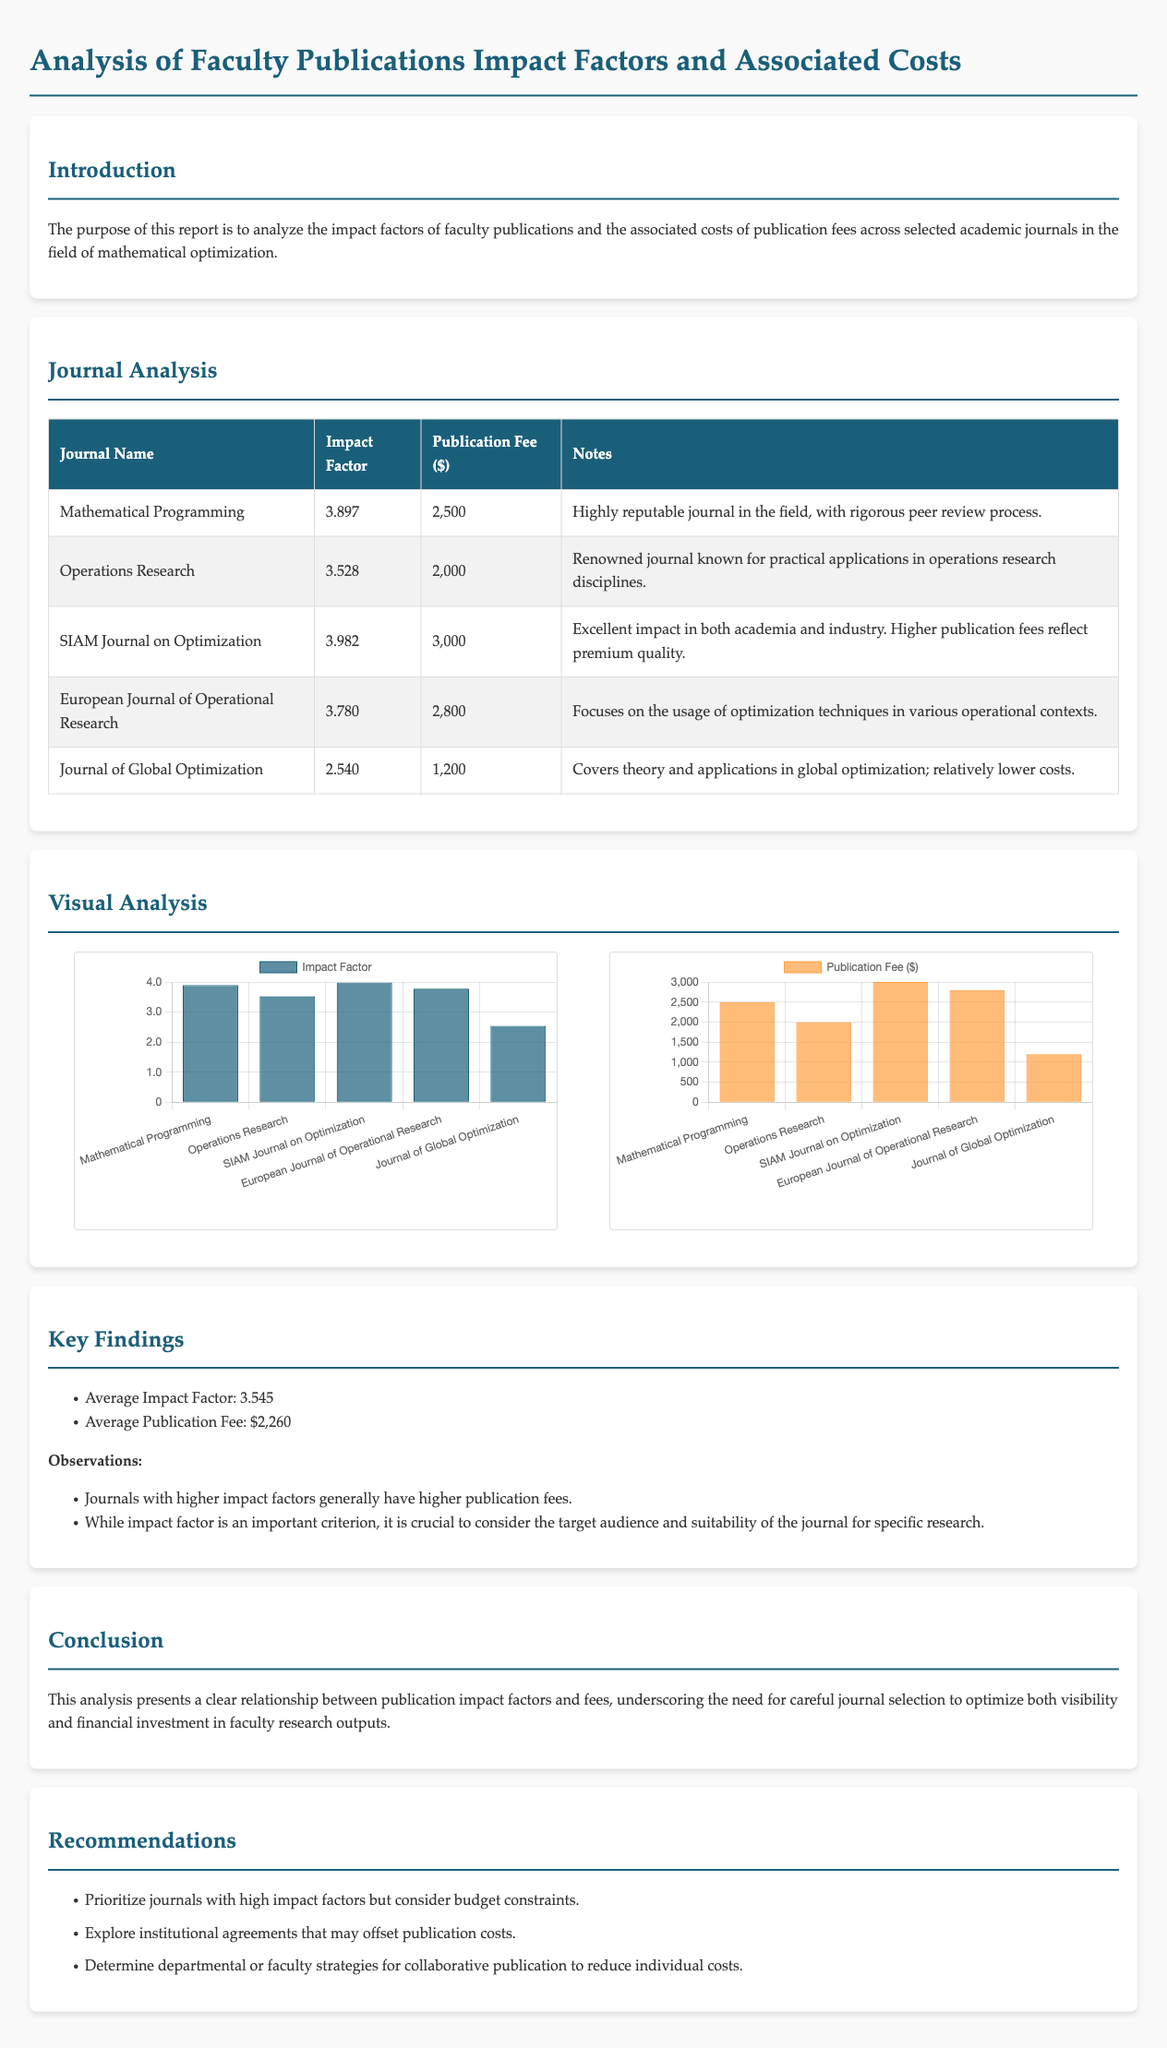What is the average impact factor of the journals? The average impact factor is stated in the Key Findings section, calculated from the listed impact factors of the journals.
Answer: 3.545 What is the publication fee for the SIAM Journal on Optimization? The publication fee for the SIAM Journal on Optimization is provided in the Journal Analysis table.
Answer: 3,000 Which journal has the highest impact factor? The journal with the highest impact factor can be identified from the Journal Analysis section.
Answer: SIAM Journal on Optimization What is the publication fee range for the journals listed? The publication fees are listed in the Journal Analysis table; the range can be determined by looking at the highest and lowest fees.
Answer: $1,200 - $3,000 Which journal is known for its rigorous peer review process? The notes in the Journal Analysis section provide specific characteristics about each journal, highlighting reputations.
Answer: Mathematical Programming What is the focus of the European Journal of Operational Research? The focus of the European Journal of Operational Research is detailed in its description in the Journal Analysis section.
Answer: Optimization techniques What are the key recommendations made in this report? The recommendations can be found in the Recommendations section of the document and summarize strategic suggestions.
Answer: High impact factors and budget constraints What does the visual analysis include? The visual analysis section specifies what kind of data is represented visually, helping to determine its content.
Answer: Charts for impact factors and publication fees 